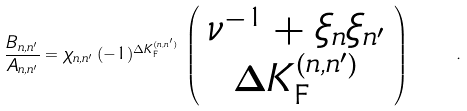<formula> <loc_0><loc_0><loc_500><loc_500>\frac { B _ { n , n ^ { \prime } } } { A _ { n , n ^ { \prime } } } = \chi _ { n , n ^ { \prime } } \, ( - 1 ) ^ { \Delta K ^ { ( n , n ^ { \prime } ) } _ { \text {F} } } \, \left ( \begin{array} { c } \nu ^ { - 1 } + \xi _ { n } \xi _ { n ^ { \prime } } \\ \Delta K ^ { ( n , n ^ { \prime } ) } _ { \text {F} } \end{array} \right ) \quad .</formula> 